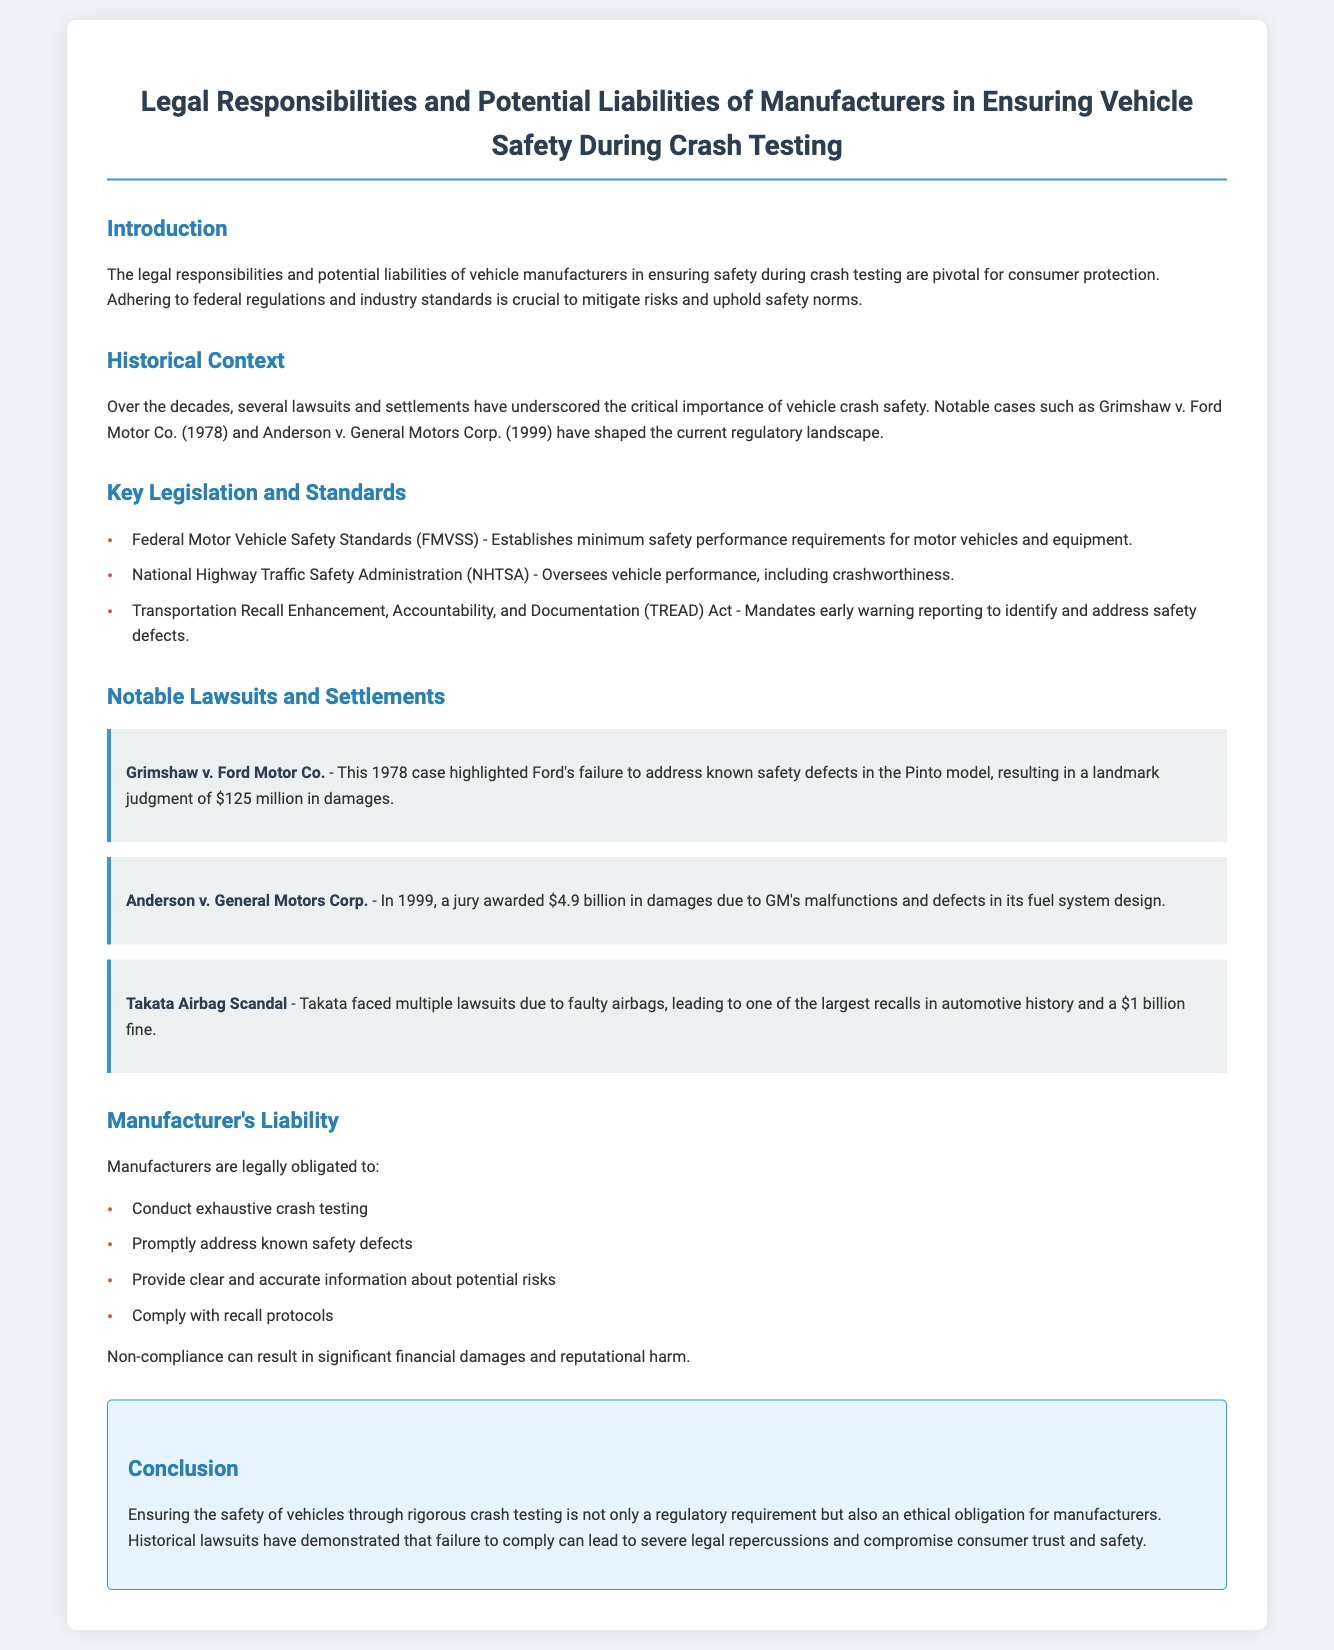what significant case highlighted Ford's failure to address safety defects? This case is mentioned in the historical context and is Grimshaw v. Ford Motor Co.
Answer: Grimshaw v. Ford Motor Co how much was awarded in damages in Anderson v. General Motors Corp.? The document states that the jury awarded $4.9 billion in damages in this case.
Answer: $4.9 billion what is the main role of the National Highway Traffic Safety Administration (NHTSA)? The document describes NHTSA's responsibility as overseeing vehicle performance, including crashworthiness.
Answer: Oversees vehicle performance what major consequence did Takata face due to faulty airbags? The document states that Takata faced multiple lawsuits and a significant fine due to faulty airbags.
Answer: $1 billion fine what legal obligation must manufacturers fulfill regarding potential risks? The document indicates that manufacturers must provide clear and accurate information about potential risks.
Answer: Provide clear and accurate information what year did the Grimshaw v. Ford Motor Co. case occur? The document provides the year in which this landmark case occurred, which is critical to understanding its historical context.
Answer: 1978 what is one of the key federal regulations mentioned in the document? The document lists several key regulations, one of which is essential for vehicle safety requirements.
Answer: Federal Motor Vehicle Safety Standards (FMVSS) what obligation does the document state manufacturers must comply with after identifying safety defects? The document explicitly discusses the need for manufacturers to address known safety defects promptly.
Answer: Promptly address known safety defects 